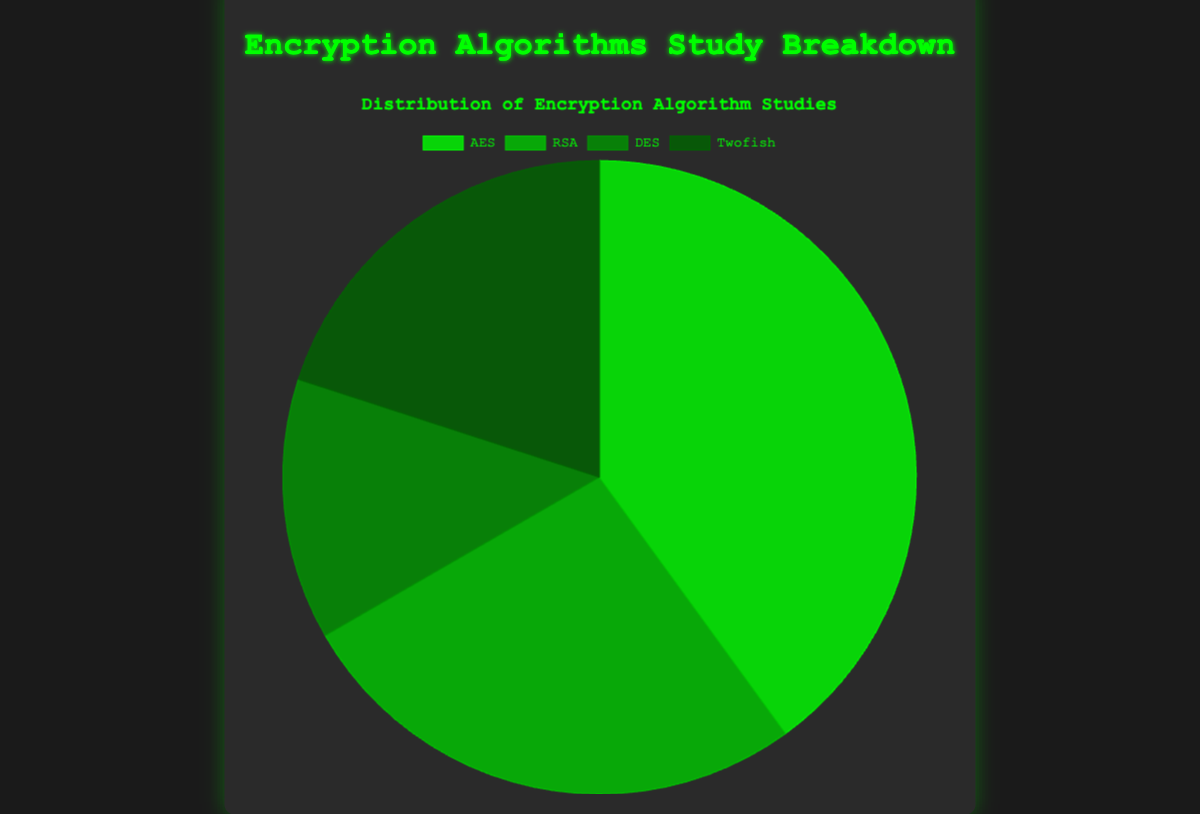What percentage of studies were dedicated to AES? To find the percentage of studies dedicated to AES, divide the number of AES studies (150) by the total number of studies (150 + 100 + 50 + 75 = 375), then multiply by 100. (150 / 375) * 100 = 40%
Answer: 40% Which encryption algorithm had the fewest studies? The chart shows that DES had 50 studies, which is fewer than the other algorithms.
Answer: DES How many more studies were conducted on AES than on DES? Subtract the number of DES studies from the number of AES studies: 150 - 50 = 100
Answer: 100 Which two encryption algorithms combined make up exactly half of the total studies? Sum the number of studies for each combination and check if it equals half the total (375 / 2 = 187.5). AES (150) + RSA (100) = 250, AES (150) + DES (50) = 200, AES (150) + Twofish (75) = 225. The combination RSA (100) + DES (50) + Twofish (75) = 225 but none of these exactly make up 187.5 so none.
Answer: None What is the ratio of AES studies to the total number of studies? The ratio is the number of AES studies divided by the total number of studies: 150 / 375
Answer: 2:5 What color represents RSA in the pie chart? The pie chart lists colors in order of the labels: AES (green), RSA (darker green), DES (another darker green), and Twofish (dark green). RSA is represented by a darker green.
Answer: Darker green If we combined the studies of AES and Twofish, what fraction of the total studies would they represent? Combine the studies of AES and Twofish: 150 + 75 = 225. Then divide by the total number of studies and simplify: 225 / 375 = 3/5 or 0.6
Answer: 0.6 or 3/5 How do the number of RSA studies compare to the total number of AES and DES studies combined? Sum the AES and DES studies: 150 + 50 = 200. RSA has 100 studies, which is less than 200.
Answer: RSA studies are less What is the difference in the number of studies between the algorithm with the highest and the algorithm with the lowest studies? The algorithm with the highest studies is AES (150) and the lowest is DES (50). The difference is 150 - 50 = 100
Answer: 100 If you were to visually compare the sections representing DES and Twofish, which one is larger? The pie chart sections show that Twofish (75) has more studies than DES (50), making Twofish visually larger.
Answer: Twofish 